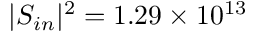<formula> <loc_0><loc_0><loc_500><loc_500>| S _ { i n } | ^ { 2 } = 1 . 2 9 \times 1 0 ^ { 1 3 }</formula> 